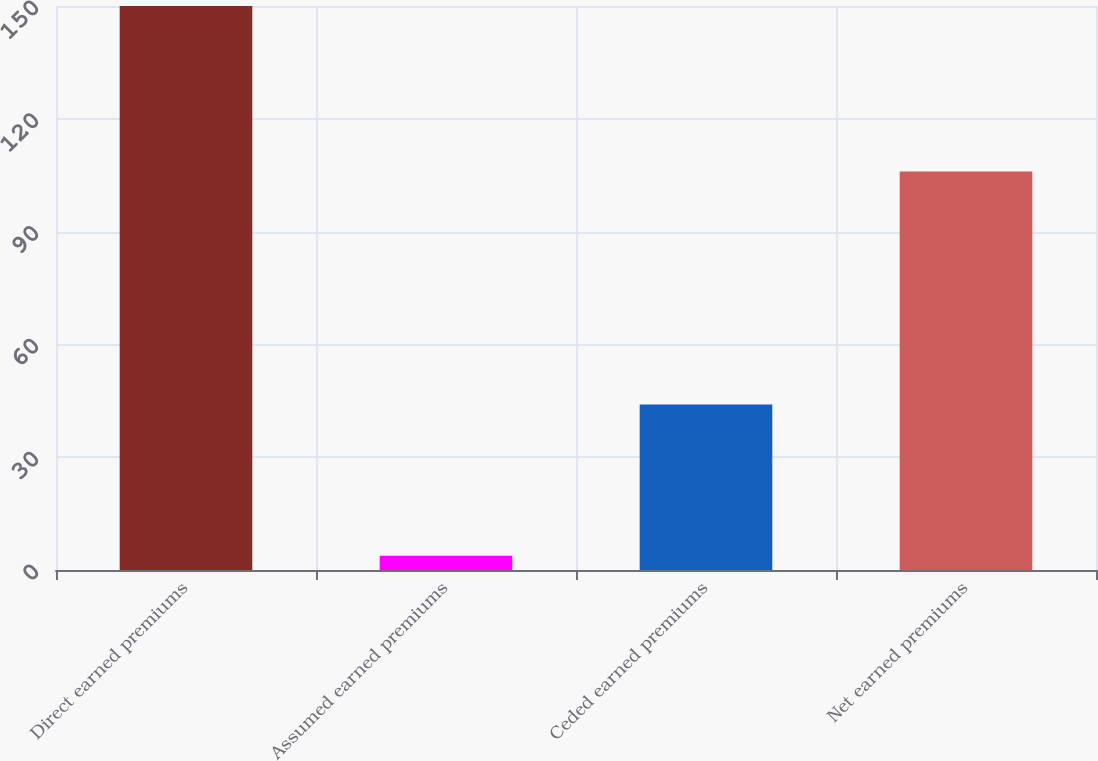Convert chart to OTSL. <chart><loc_0><loc_0><loc_500><loc_500><bar_chart><fcel>Direct earned premiums<fcel>Assumed earned premiums<fcel>Ceded earned premiums<fcel>Net earned premiums<nl><fcel>150<fcel>3.82<fcel>44<fcel>106<nl></chart> 